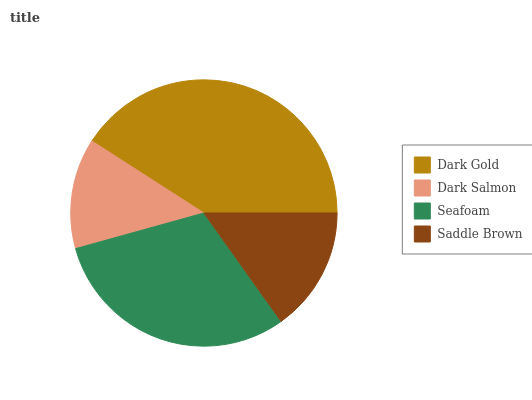Is Dark Salmon the minimum?
Answer yes or no. Yes. Is Dark Gold the maximum?
Answer yes or no. Yes. Is Seafoam the minimum?
Answer yes or no. No. Is Seafoam the maximum?
Answer yes or no. No. Is Seafoam greater than Dark Salmon?
Answer yes or no. Yes. Is Dark Salmon less than Seafoam?
Answer yes or no. Yes. Is Dark Salmon greater than Seafoam?
Answer yes or no. No. Is Seafoam less than Dark Salmon?
Answer yes or no. No. Is Seafoam the high median?
Answer yes or no. Yes. Is Saddle Brown the low median?
Answer yes or no. Yes. Is Dark Gold the high median?
Answer yes or no. No. Is Dark Gold the low median?
Answer yes or no. No. 